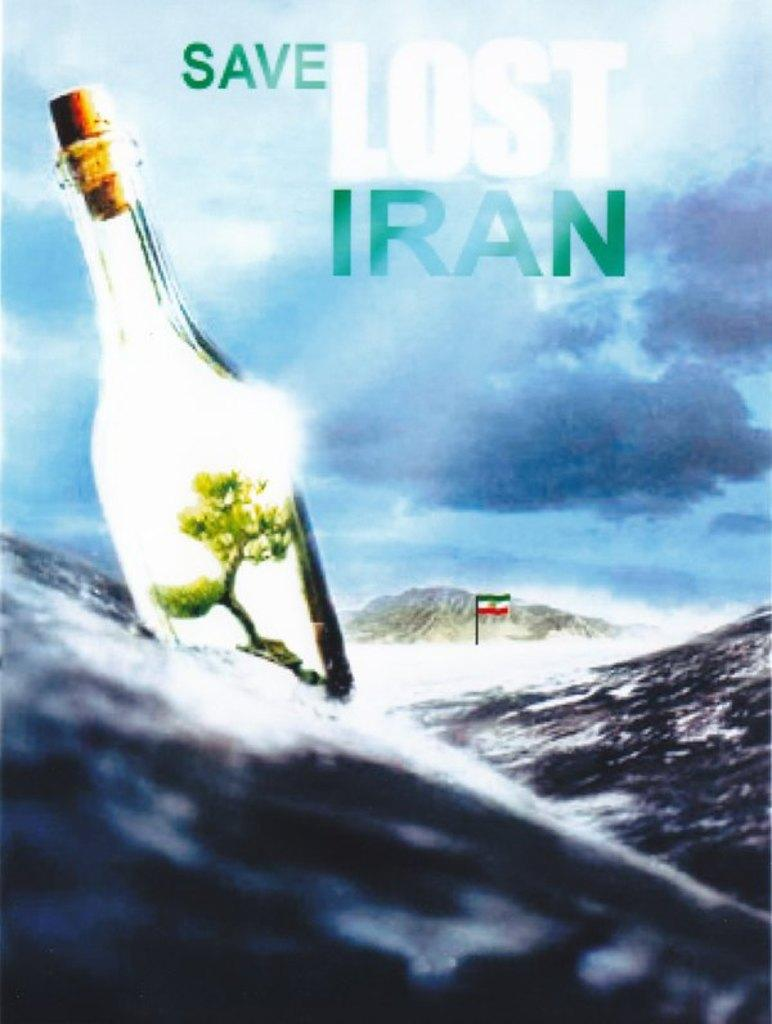<image>
Provide a brief description of the given image. a poster of a bottle in the ocean that says 'save lost iran' on it 